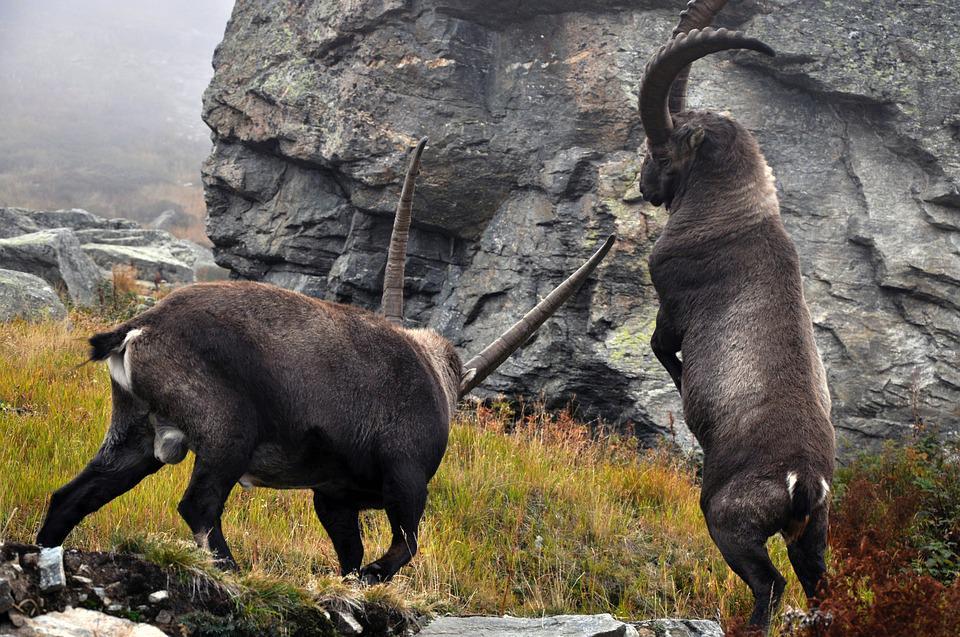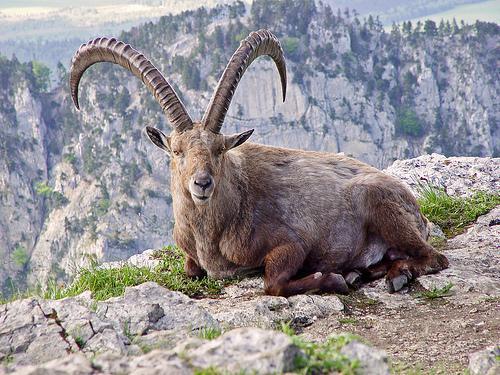The first image is the image on the left, the second image is the image on the right. For the images displayed, is the sentence "There are more rams in the image on the left." factually correct? Answer yes or no. Yes. The first image is the image on the left, the second image is the image on the right. Analyze the images presented: Is the assertion "A mountain goat stands on its hinds legs in front of a similarly colored horned animal." valid? Answer yes or no. Yes. The first image is the image on the left, the second image is the image on the right. Evaluate the accuracy of this statement regarding the images: "The left image contains exactly two mountain goats.". Is it true? Answer yes or no. Yes. The first image is the image on the left, the second image is the image on the right. Assess this claim about the two images: "The right image contains exactly one mountain goat on a rocky cliff.". Correct or not? Answer yes or no. Yes. 